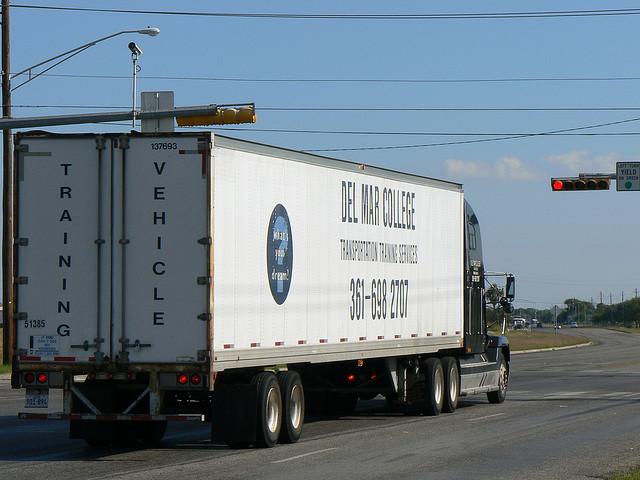Is this a professional driver?
Keep it brief. Yes. What is the phone# on the bus?
Short answer required. 361-698-2707. Is the truck on a sidewalk?
Quick response, please. No. What college is this truck going to?
Be succinct. Del mar. What are all along the bottom of the semi truck?
Write a very short answer. Tires. 